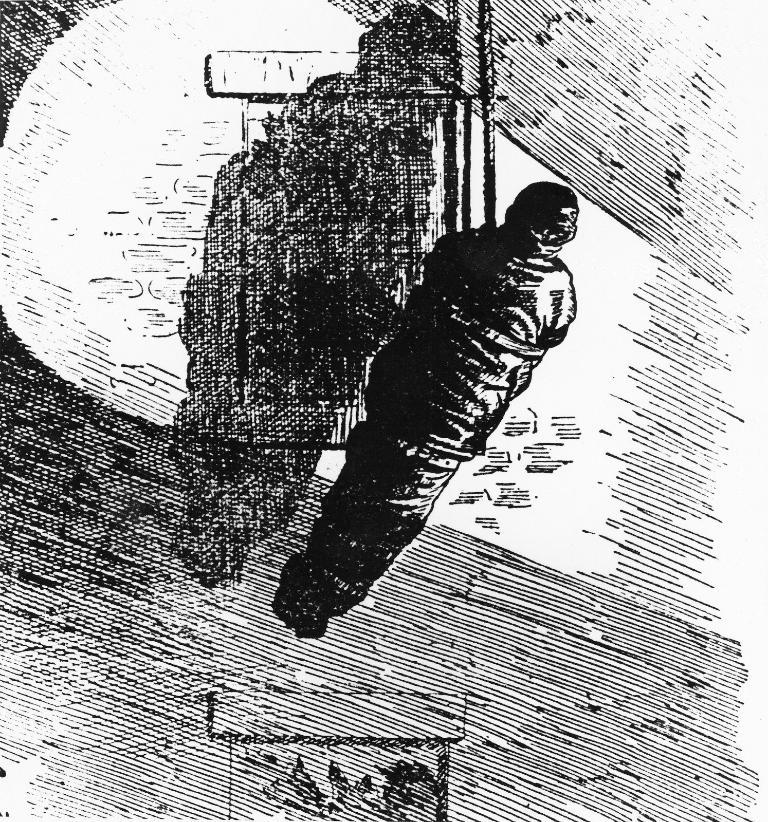What style is the image presented in? The image appears to be a sketch. What is the main subject of the sketch? There is a person in the sketch. What is the person's condition in the sketch? The person is tied with a rope in the sketch. What type of vacation is the person planning in the sketch? There is no indication of a vacation or any planning in the sketch; it simply depicts a person tied with a rope. How many parcels can be seen in the sketch? There are no parcels present in the sketch. 